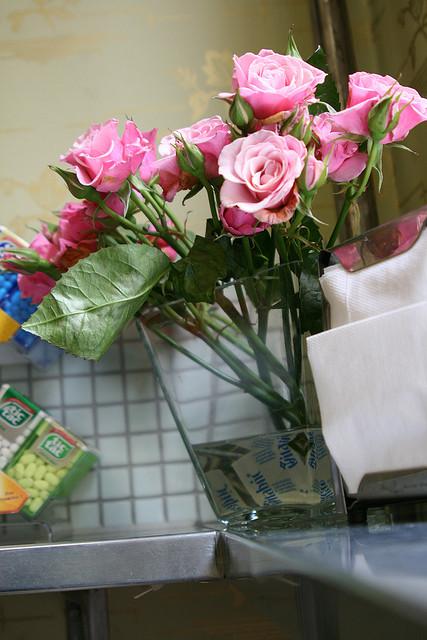How does the recipient of these roses feel?
Concise answer only. Happy. What two colors are the pictured tic-tacs?
Give a very brief answer. Yellow and white. What color is the stem of the flowers?
Answer briefly. Green. How many flavors of tic tacs are there?
Answer briefly. 2. How many roses are in the vase?
Quick response, please. 8. 